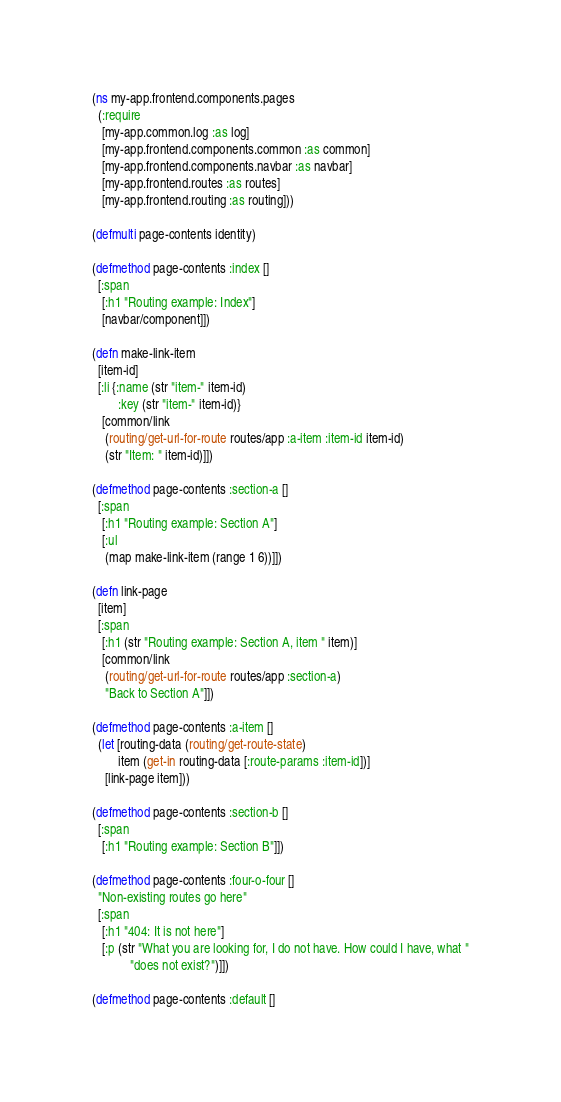Convert code to text. <code><loc_0><loc_0><loc_500><loc_500><_Clojure_>(ns my-app.frontend.components.pages
  (:require
   [my-app.common.log :as log]
   [my-app.frontend.components.common :as common]
   [my-app.frontend.components.navbar :as navbar]
   [my-app.frontend.routes :as routes]
   [my-app.frontend.routing :as routing]))

(defmulti page-contents identity)

(defmethod page-contents :index []
  [:span
   [:h1 "Routing example: Index"]
   [navbar/component]])

(defn make-link-item
  [item-id]
  [:li {:name (str "item-" item-id)
        :key (str "item-" item-id)}
   [common/link
    (routing/get-url-for-route routes/app :a-item :item-id item-id)
    (str "Item: " item-id)]])

(defmethod page-contents :section-a []
  [:span
   [:h1 "Routing example: Section A"]
   [:ul
    (map make-link-item (range 1 6))]])

(defn link-page
  [item]
  [:span
   [:h1 (str "Routing example: Section A, item " item)]
   [common/link
    (routing/get-url-for-route routes/app :section-a)
    "Back to Section A"]])

(defmethod page-contents :a-item []
  (let [routing-data (routing/get-route-state)
        item (get-in routing-data [:route-params :item-id])]
    [link-page item]))

(defmethod page-contents :section-b []
  [:span
   [:h1 "Routing example: Section B"]])

(defmethod page-contents :four-o-four []
  "Non-existing routes go here"
  [:span
   [:h1 "404: It is not here"]
   [:p (str "What you are looking for, I do not have. How could I have, what "
            "does not exist?")]])

(defmethod page-contents :default []</code> 